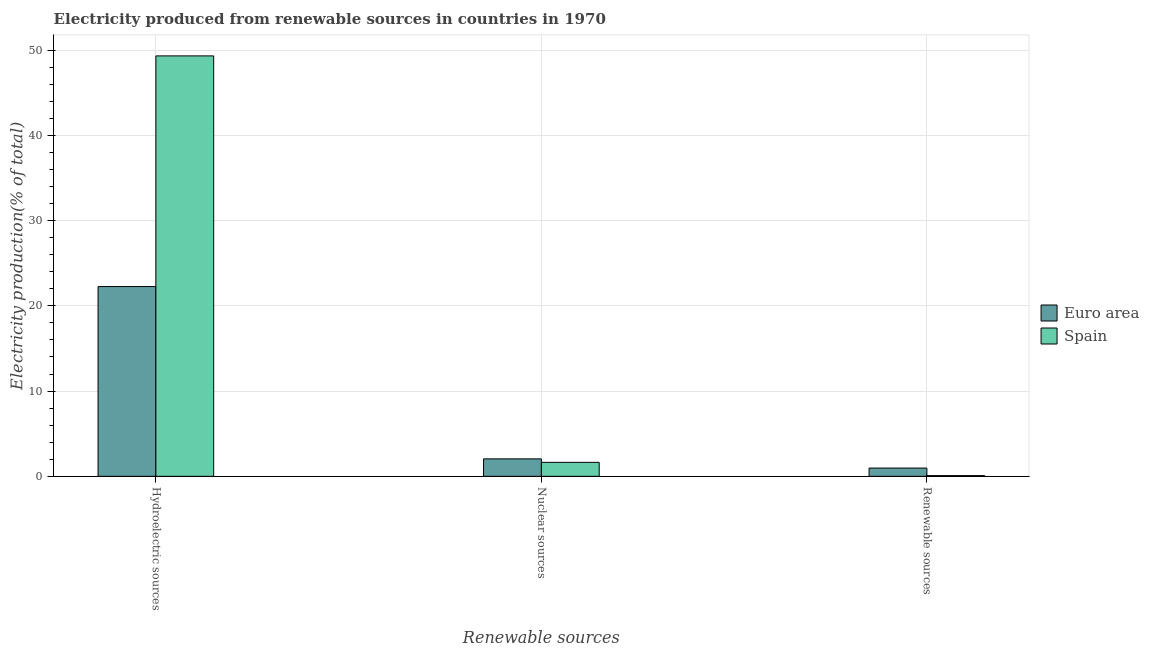How many different coloured bars are there?
Your answer should be compact. 2. How many groups of bars are there?
Keep it short and to the point. 3. Are the number of bars on each tick of the X-axis equal?
Provide a succinct answer. Yes. How many bars are there on the 3rd tick from the left?
Keep it short and to the point. 2. What is the label of the 3rd group of bars from the left?
Provide a short and direct response. Renewable sources. What is the percentage of electricity produced by hydroelectric sources in Euro area?
Give a very brief answer. 22.26. Across all countries, what is the maximum percentage of electricity produced by nuclear sources?
Ensure brevity in your answer.  2.05. Across all countries, what is the minimum percentage of electricity produced by renewable sources?
Your response must be concise. 0.08. In which country was the percentage of electricity produced by hydroelectric sources maximum?
Your answer should be compact. Spain. What is the total percentage of electricity produced by nuclear sources in the graph?
Make the answer very short. 3.69. What is the difference between the percentage of electricity produced by hydroelectric sources in Spain and that in Euro area?
Keep it short and to the point. 27.06. What is the difference between the percentage of electricity produced by hydroelectric sources in Spain and the percentage of electricity produced by renewable sources in Euro area?
Give a very brief answer. 48.36. What is the average percentage of electricity produced by hydroelectric sources per country?
Ensure brevity in your answer.  35.8. What is the difference between the percentage of electricity produced by hydroelectric sources and percentage of electricity produced by nuclear sources in Spain?
Your answer should be compact. 47.69. What is the ratio of the percentage of electricity produced by renewable sources in Euro area to that in Spain?
Provide a short and direct response. 11.59. Is the percentage of electricity produced by hydroelectric sources in Euro area less than that in Spain?
Ensure brevity in your answer.  Yes. Is the difference between the percentage of electricity produced by renewable sources in Euro area and Spain greater than the difference between the percentage of electricity produced by hydroelectric sources in Euro area and Spain?
Your answer should be very brief. Yes. What is the difference between the highest and the second highest percentage of electricity produced by hydroelectric sources?
Your response must be concise. 27.06. What is the difference between the highest and the lowest percentage of electricity produced by renewable sources?
Provide a succinct answer. 0.88. Is the sum of the percentage of electricity produced by nuclear sources in Euro area and Spain greater than the maximum percentage of electricity produced by hydroelectric sources across all countries?
Ensure brevity in your answer.  No. What does the 2nd bar from the right in Nuclear sources represents?
Provide a succinct answer. Euro area. Is it the case that in every country, the sum of the percentage of electricity produced by hydroelectric sources and percentage of electricity produced by nuclear sources is greater than the percentage of electricity produced by renewable sources?
Keep it short and to the point. Yes. Are the values on the major ticks of Y-axis written in scientific E-notation?
Your answer should be very brief. No. Does the graph contain any zero values?
Offer a very short reply. No. Where does the legend appear in the graph?
Provide a succinct answer. Center right. How many legend labels are there?
Your answer should be compact. 2. How are the legend labels stacked?
Make the answer very short. Vertical. What is the title of the graph?
Your answer should be very brief. Electricity produced from renewable sources in countries in 1970. What is the label or title of the X-axis?
Provide a short and direct response. Renewable sources. What is the Electricity production(% of total) of Euro area in Hydroelectric sources?
Provide a short and direct response. 22.26. What is the Electricity production(% of total) of Spain in Hydroelectric sources?
Make the answer very short. 49.33. What is the Electricity production(% of total) of Euro area in Nuclear sources?
Keep it short and to the point. 2.05. What is the Electricity production(% of total) in Spain in Nuclear sources?
Provide a short and direct response. 1.64. What is the Electricity production(% of total) of Euro area in Renewable sources?
Your answer should be compact. 0.97. What is the Electricity production(% of total) of Spain in Renewable sources?
Your answer should be compact. 0.08. Across all Renewable sources, what is the maximum Electricity production(% of total) in Euro area?
Offer a terse response. 22.26. Across all Renewable sources, what is the maximum Electricity production(% of total) in Spain?
Offer a very short reply. 49.33. Across all Renewable sources, what is the minimum Electricity production(% of total) in Euro area?
Offer a very short reply. 0.97. Across all Renewable sources, what is the minimum Electricity production(% of total) of Spain?
Ensure brevity in your answer.  0.08. What is the total Electricity production(% of total) of Euro area in the graph?
Your answer should be compact. 25.28. What is the total Electricity production(% of total) in Spain in the graph?
Keep it short and to the point. 51.05. What is the difference between the Electricity production(% of total) in Euro area in Hydroelectric sources and that in Nuclear sources?
Ensure brevity in your answer.  20.22. What is the difference between the Electricity production(% of total) in Spain in Hydroelectric sources and that in Nuclear sources?
Keep it short and to the point. 47.69. What is the difference between the Electricity production(% of total) in Euro area in Hydroelectric sources and that in Renewable sources?
Make the answer very short. 21.3. What is the difference between the Electricity production(% of total) in Spain in Hydroelectric sources and that in Renewable sources?
Provide a short and direct response. 49.24. What is the difference between the Electricity production(% of total) in Euro area in Nuclear sources and that in Renewable sources?
Your answer should be compact. 1.08. What is the difference between the Electricity production(% of total) in Spain in Nuclear sources and that in Renewable sources?
Your response must be concise. 1.56. What is the difference between the Electricity production(% of total) in Euro area in Hydroelectric sources and the Electricity production(% of total) in Spain in Nuclear sources?
Your answer should be compact. 20.63. What is the difference between the Electricity production(% of total) in Euro area in Hydroelectric sources and the Electricity production(% of total) in Spain in Renewable sources?
Make the answer very short. 22.18. What is the difference between the Electricity production(% of total) of Euro area in Nuclear sources and the Electricity production(% of total) of Spain in Renewable sources?
Ensure brevity in your answer.  1.96. What is the average Electricity production(% of total) in Euro area per Renewable sources?
Offer a very short reply. 8.43. What is the average Electricity production(% of total) in Spain per Renewable sources?
Provide a succinct answer. 17.02. What is the difference between the Electricity production(% of total) in Euro area and Electricity production(% of total) in Spain in Hydroelectric sources?
Give a very brief answer. -27.06. What is the difference between the Electricity production(% of total) in Euro area and Electricity production(% of total) in Spain in Nuclear sources?
Your answer should be very brief. 0.41. What is the difference between the Electricity production(% of total) of Euro area and Electricity production(% of total) of Spain in Renewable sources?
Offer a very short reply. 0.88. What is the ratio of the Electricity production(% of total) of Euro area in Hydroelectric sources to that in Nuclear sources?
Provide a short and direct response. 10.88. What is the ratio of the Electricity production(% of total) in Spain in Hydroelectric sources to that in Nuclear sources?
Offer a terse response. 30.09. What is the ratio of the Electricity production(% of total) of Euro area in Hydroelectric sources to that in Renewable sources?
Provide a short and direct response. 23.01. What is the ratio of the Electricity production(% of total) of Spain in Hydroelectric sources to that in Renewable sources?
Provide a short and direct response. 590.89. What is the ratio of the Electricity production(% of total) in Euro area in Nuclear sources to that in Renewable sources?
Offer a very short reply. 2.12. What is the ratio of the Electricity production(% of total) in Spain in Nuclear sources to that in Renewable sources?
Keep it short and to the point. 19.64. What is the difference between the highest and the second highest Electricity production(% of total) of Euro area?
Offer a terse response. 20.22. What is the difference between the highest and the second highest Electricity production(% of total) of Spain?
Give a very brief answer. 47.69. What is the difference between the highest and the lowest Electricity production(% of total) of Euro area?
Keep it short and to the point. 21.3. What is the difference between the highest and the lowest Electricity production(% of total) of Spain?
Keep it short and to the point. 49.24. 